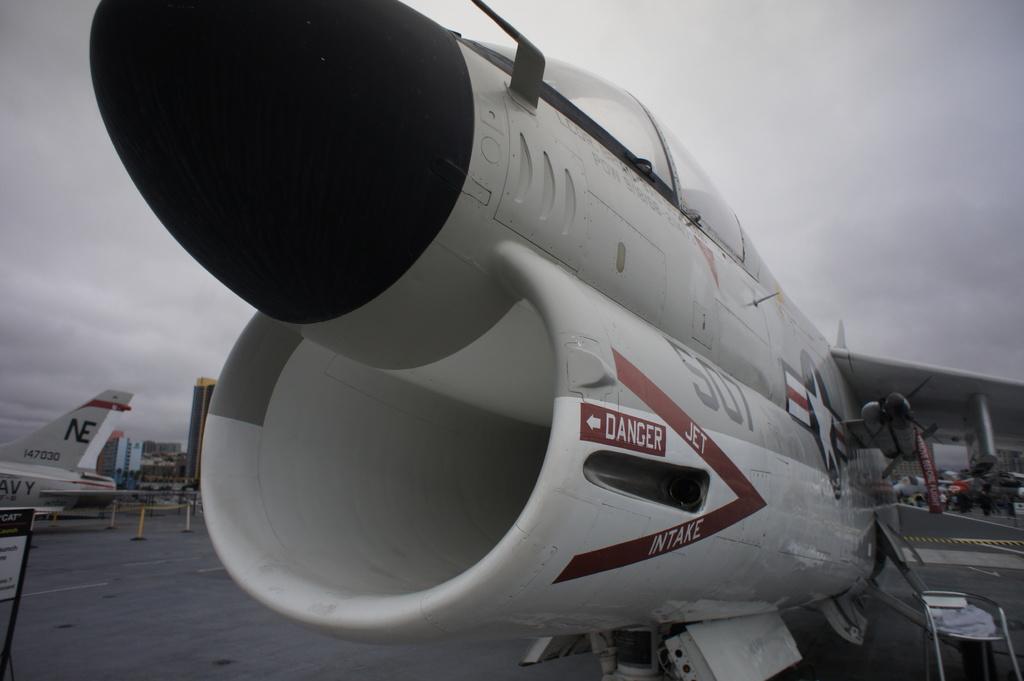What does the engine say?
Give a very brief answer. Danger. What is the plane number?
Give a very brief answer. 507. 